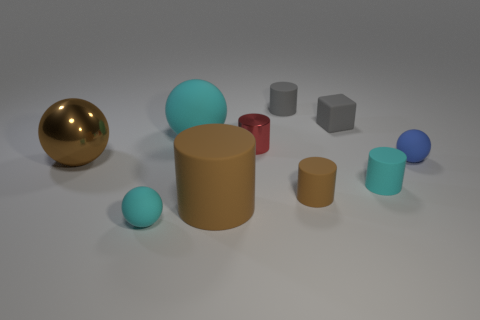The other brown cylinder that is the same material as the tiny brown cylinder is what size?
Ensure brevity in your answer.  Large. Are there any small objects that have the same color as the big cylinder?
Make the answer very short. Yes. Does the matte cylinder left of the gray matte cylinder have the same color as the metal object that is left of the shiny cylinder?
Give a very brief answer. Yes. The thing that is the same color as the rubber block is what size?
Offer a terse response. Small. Is the color of the tiny matte object that is in front of the tiny brown cylinder the same as the large rubber sphere?
Your answer should be very brief. Yes. There is a gray matte cube; what number of metallic cylinders are to the left of it?
Keep it short and to the point. 1. Is the number of small rubber blocks greater than the number of big red things?
Offer a terse response. Yes. What is the shape of the cyan matte thing to the right of the cylinder that is behind the gray rubber block?
Provide a succinct answer. Cylinder. Do the small block and the large rubber sphere have the same color?
Your answer should be compact. No. Is the number of big brown matte cylinders behind the large cylinder greater than the number of gray rubber cubes?
Provide a succinct answer. No. 